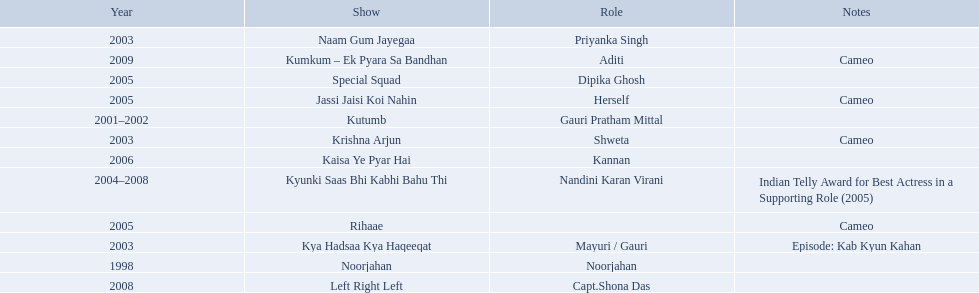In 1998 what was the role of gauri pradhan tejwani? Noorjahan. In 2003 what show did gauri have a cameo in? Krishna Arjun. Gauri was apart of which television show for the longest? Kyunki Saas Bhi Kabhi Bahu Thi. What shows was gauri tejwani in? Noorjahan, Kutumb, Krishna Arjun, Naam Gum Jayegaa, Kya Hadsaa Kya Haqeeqat, Kyunki Saas Bhi Kabhi Bahu Thi, Rihaae, Jassi Jaisi Koi Nahin, Special Squad, Kaisa Ye Pyar Hai, Left Right Left, Kumkum – Ek Pyara Sa Bandhan. What were the 2005 shows? Rihaae, Jassi Jaisi Koi Nahin, Special Squad. Which were cameos? Rihaae, Jassi Jaisi Koi Nahin. Of which of these it was not rihaee? Jassi Jaisi Koi Nahin. 